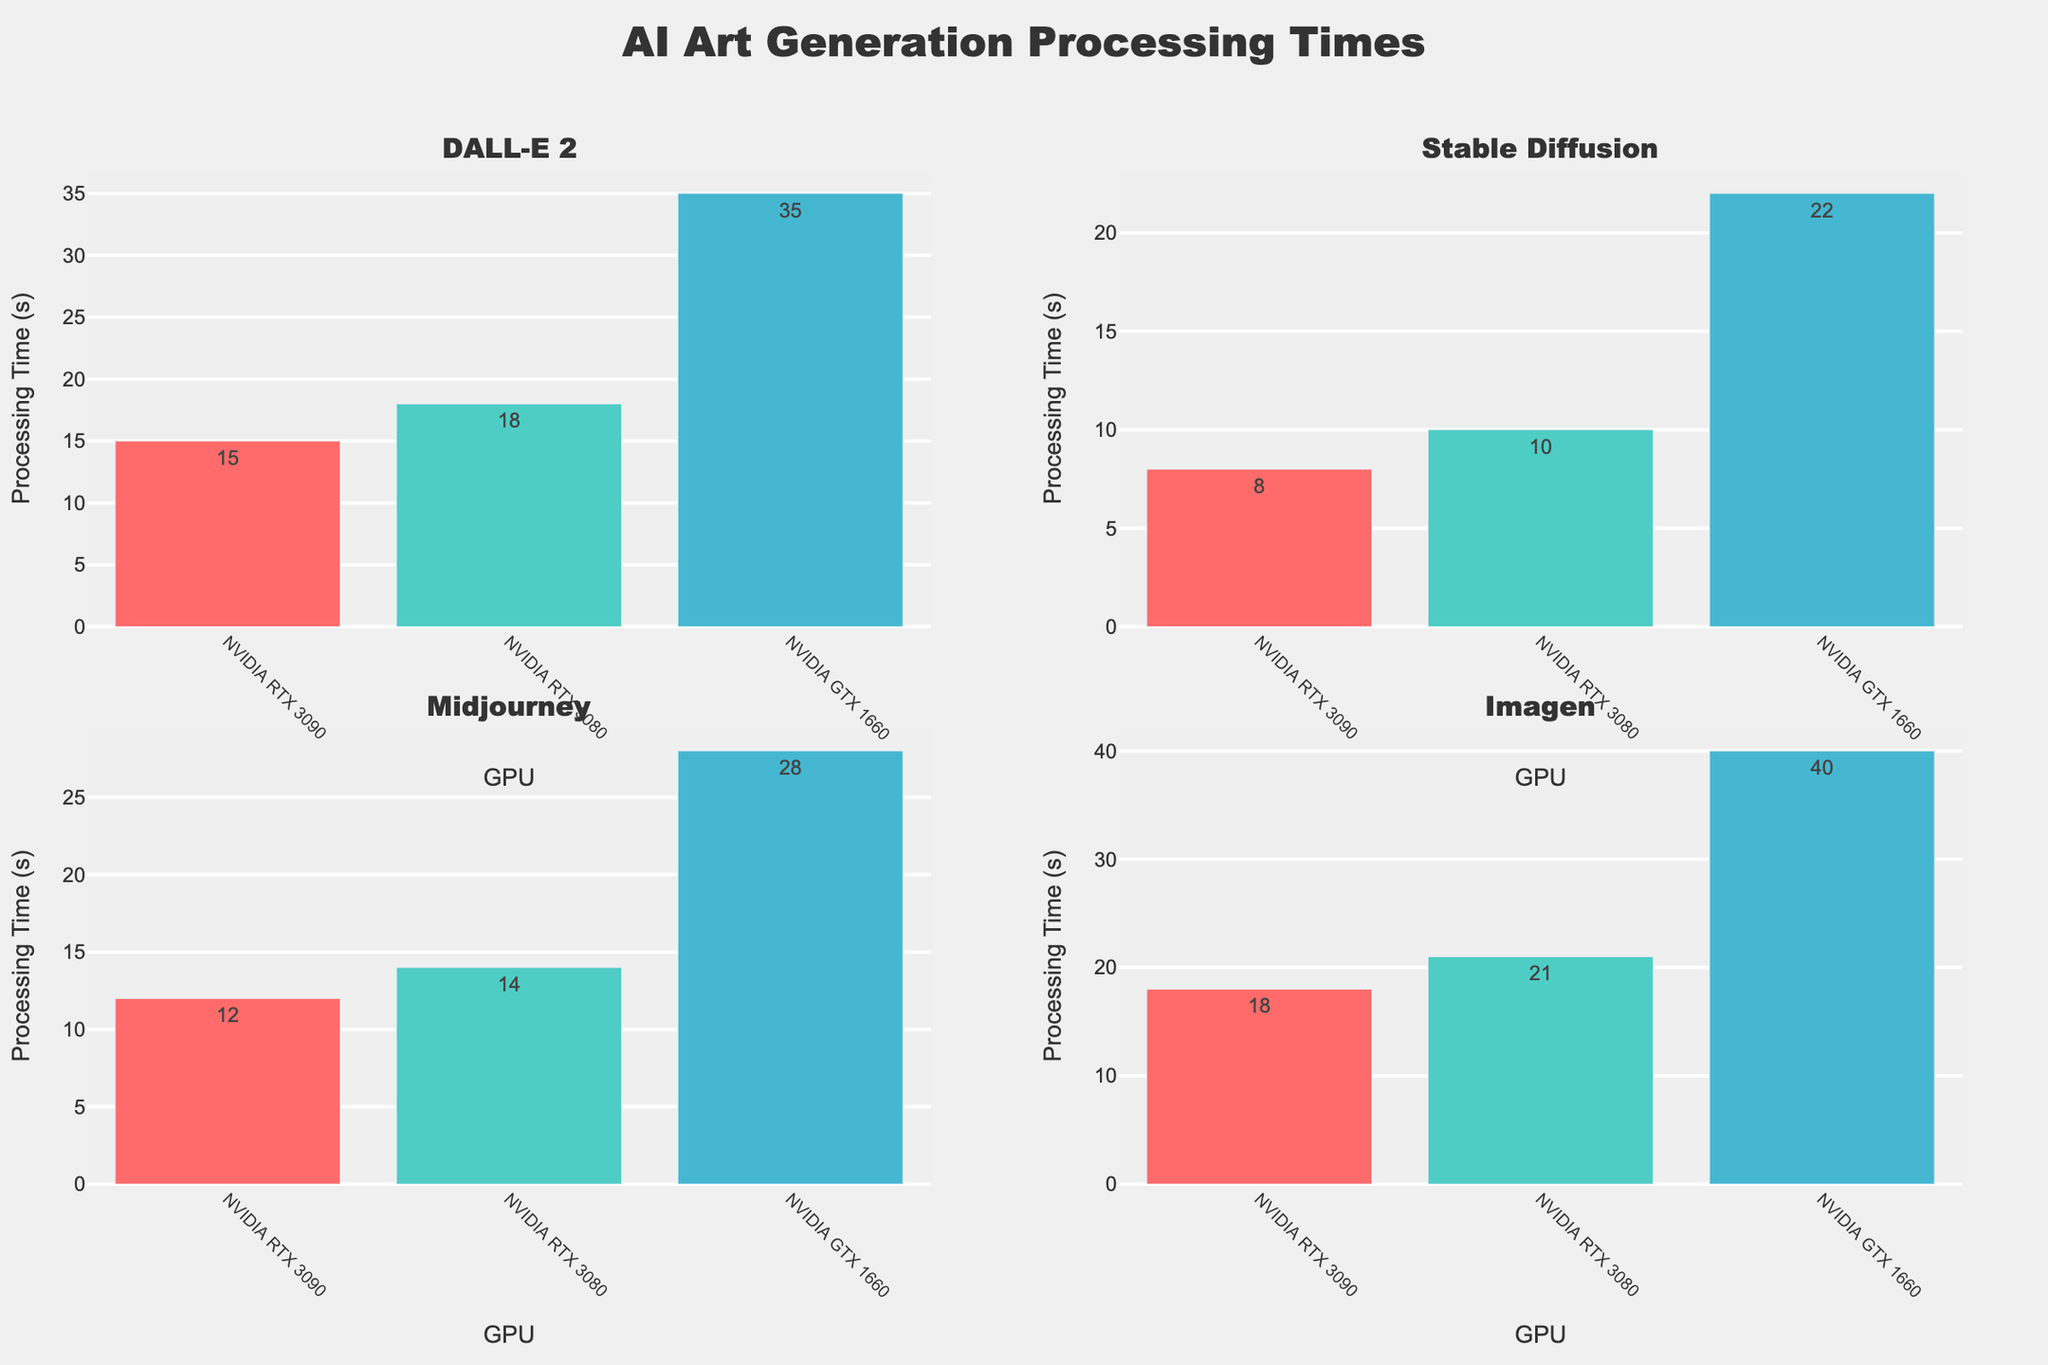What is the title of the plot? The title of the plot is prominently displayed at the top of the figure indicating the content of the visualization.
Answer: Character Development Arcs in Mad Men How does Don Draper's development arc change from Season 1 to Season 7? By observing Don Draper's subplot, the line graph shows that his development arc starts at 3 in Season 1, peaks at 6 in Season 4, declines to 4 in Season 6, and ends at 7 in Season 7.
Answer: It increases overall with a peak in Season 4 Which character has a consistently increasing development arc across all seasons? Observing all subplots, Peggy Olson is the character whose arc consistently increases each season, starting at 2 in Season 1 and reaching 8 in Season 7.
Answer: Peggy Olson In which season does Roger Sterling's development arc peak? Looking at Roger Sterling's subplot, the highest point is in Season 4, where his development arc reaches 5.
Answer: Season 4 How does Betty Draper's development arc compare from Season 1 to Season 7? Betty Draper's subplot shows her development at 3 in Season 1, peaking at 5 in Season 3, and then dropping to 2 in Season 6 before slightly rising to 4 in Season 7.
Answer: It generally decreases with minor fluctuations Which character has the most dramatic increase from one season to another? Analyzing all subplots, Peggy Olson shows the most dramatic increase, from Season 4 to Season 5, where her development arc jumps from 5 to 6.
Answer: Peggy Olson (Season 4 to Season 5) Compare Sally Draper’s development arc in Season 1 versus Season 7. Sally Draper's subplot starts at 1 in Season 1 and ends at 7 in Season 7, indicating a significant increase over time.
Answer: 1 in Season 1 and 7 in Season 7 Which characters’ arcs intersect in Season 4? By observing the subplots, Don Draper and Betty Draper both have a development arc value of 6 in Season 4.
Answer: Don Draper and Betty Draper What is the range of values depicted on the y-axis? The y-axis across all subplots ranges from 0 to 9 with a tick interval of 2.
Answer: 0 to 9 